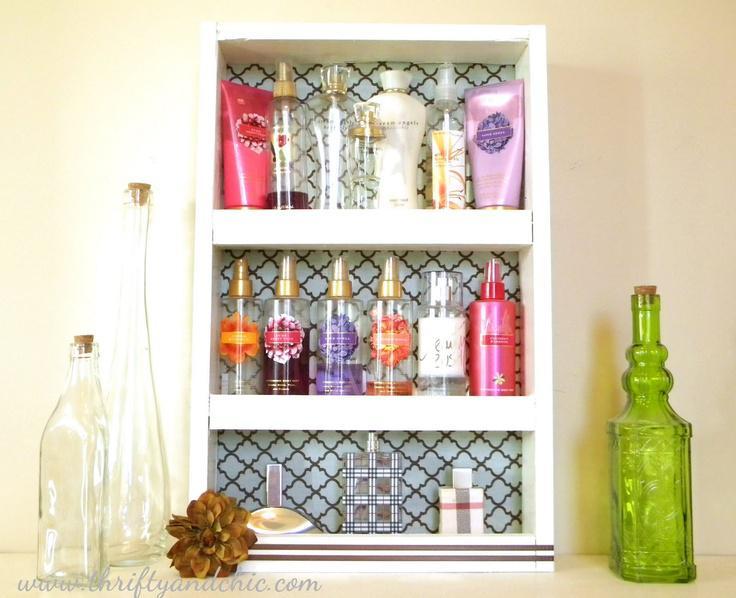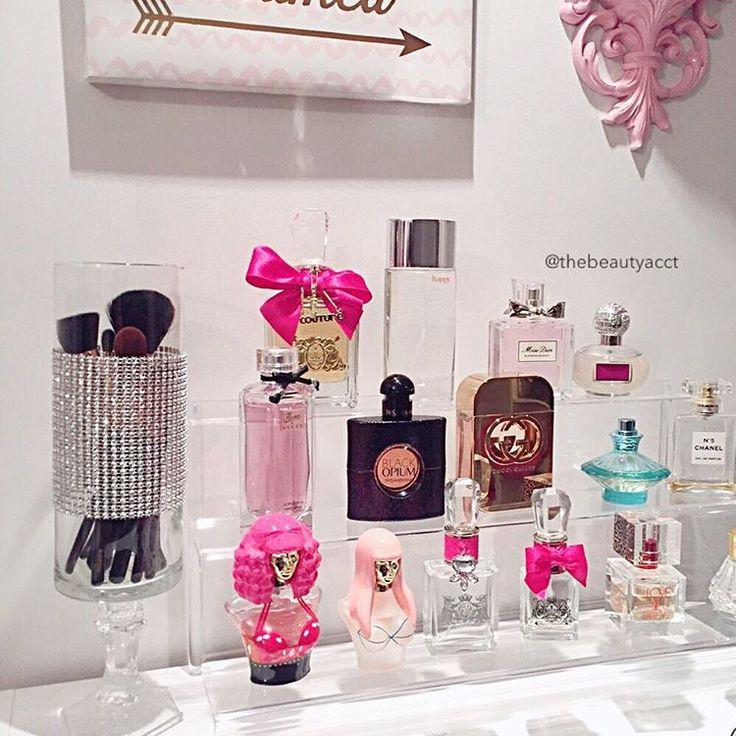The first image is the image on the left, the second image is the image on the right. For the images shown, is this caption "Each image features one display with multiple levels, and one image shows a white wall-mounted display with scrolling shapes on the top and bottom." true? Answer yes or no. No. The first image is the image on the left, the second image is the image on the right. For the images shown, is this caption "There are two tiers of shelves in the display in the image on the right." true? Answer yes or no. No. 